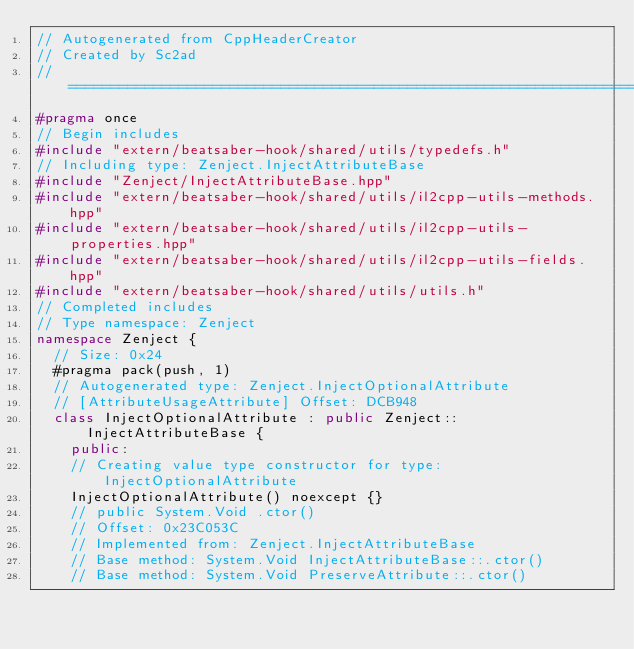Convert code to text. <code><loc_0><loc_0><loc_500><loc_500><_C++_>// Autogenerated from CppHeaderCreator
// Created by Sc2ad
// =========================================================================
#pragma once
// Begin includes
#include "extern/beatsaber-hook/shared/utils/typedefs.h"
// Including type: Zenject.InjectAttributeBase
#include "Zenject/InjectAttributeBase.hpp"
#include "extern/beatsaber-hook/shared/utils/il2cpp-utils-methods.hpp"
#include "extern/beatsaber-hook/shared/utils/il2cpp-utils-properties.hpp"
#include "extern/beatsaber-hook/shared/utils/il2cpp-utils-fields.hpp"
#include "extern/beatsaber-hook/shared/utils/utils.h"
// Completed includes
// Type namespace: Zenject
namespace Zenject {
  // Size: 0x24
  #pragma pack(push, 1)
  // Autogenerated type: Zenject.InjectOptionalAttribute
  // [AttributeUsageAttribute] Offset: DCB948
  class InjectOptionalAttribute : public Zenject::InjectAttributeBase {
    public:
    // Creating value type constructor for type: InjectOptionalAttribute
    InjectOptionalAttribute() noexcept {}
    // public System.Void .ctor()
    // Offset: 0x23C053C
    // Implemented from: Zenject.InjectAttributeBase
    // Base method: System.Void InjectAttributeBase::.ctor()
    // Base method: System.Void PreserveAttribute::.ctor()</code> 